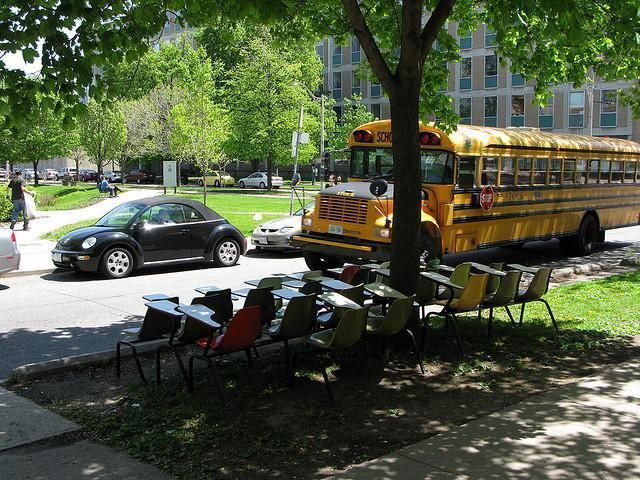How many chairs are in the picture?
Give a very brief answer. 4. How many buses can be seen?
Give a very brief answer. 1. 